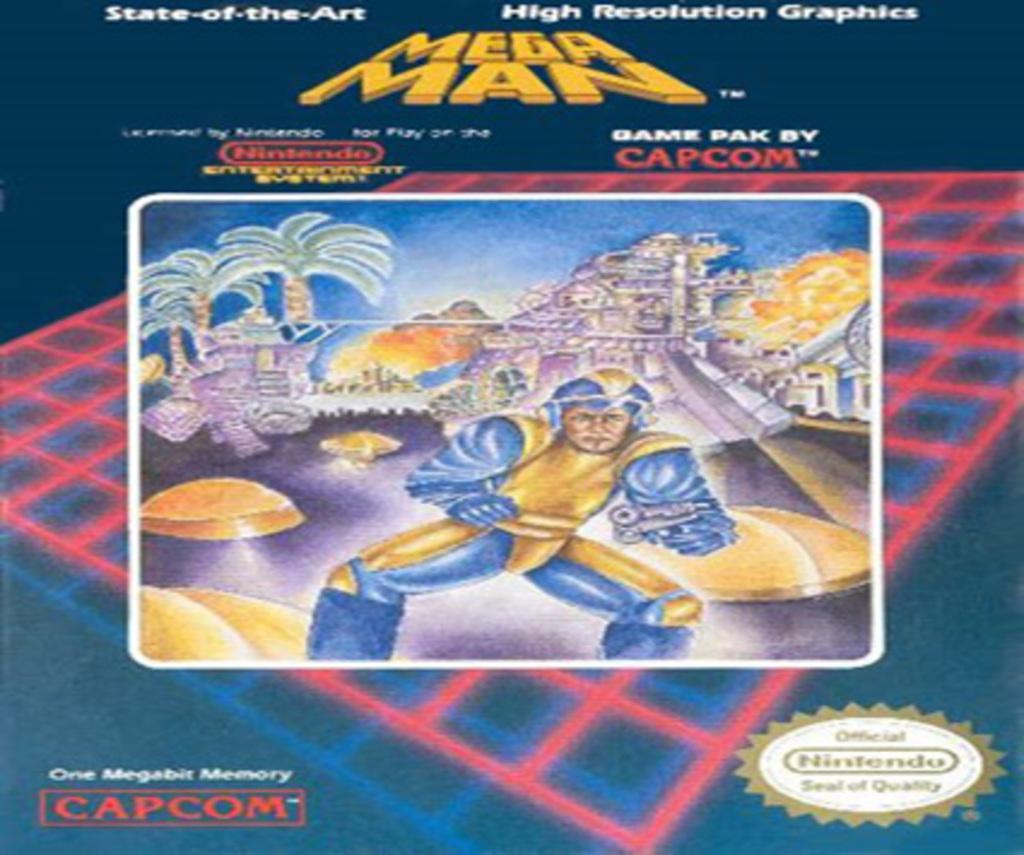Can you describe this image briefly? This is an animated picture, in this picture we can see trees and a person and it is written something. 